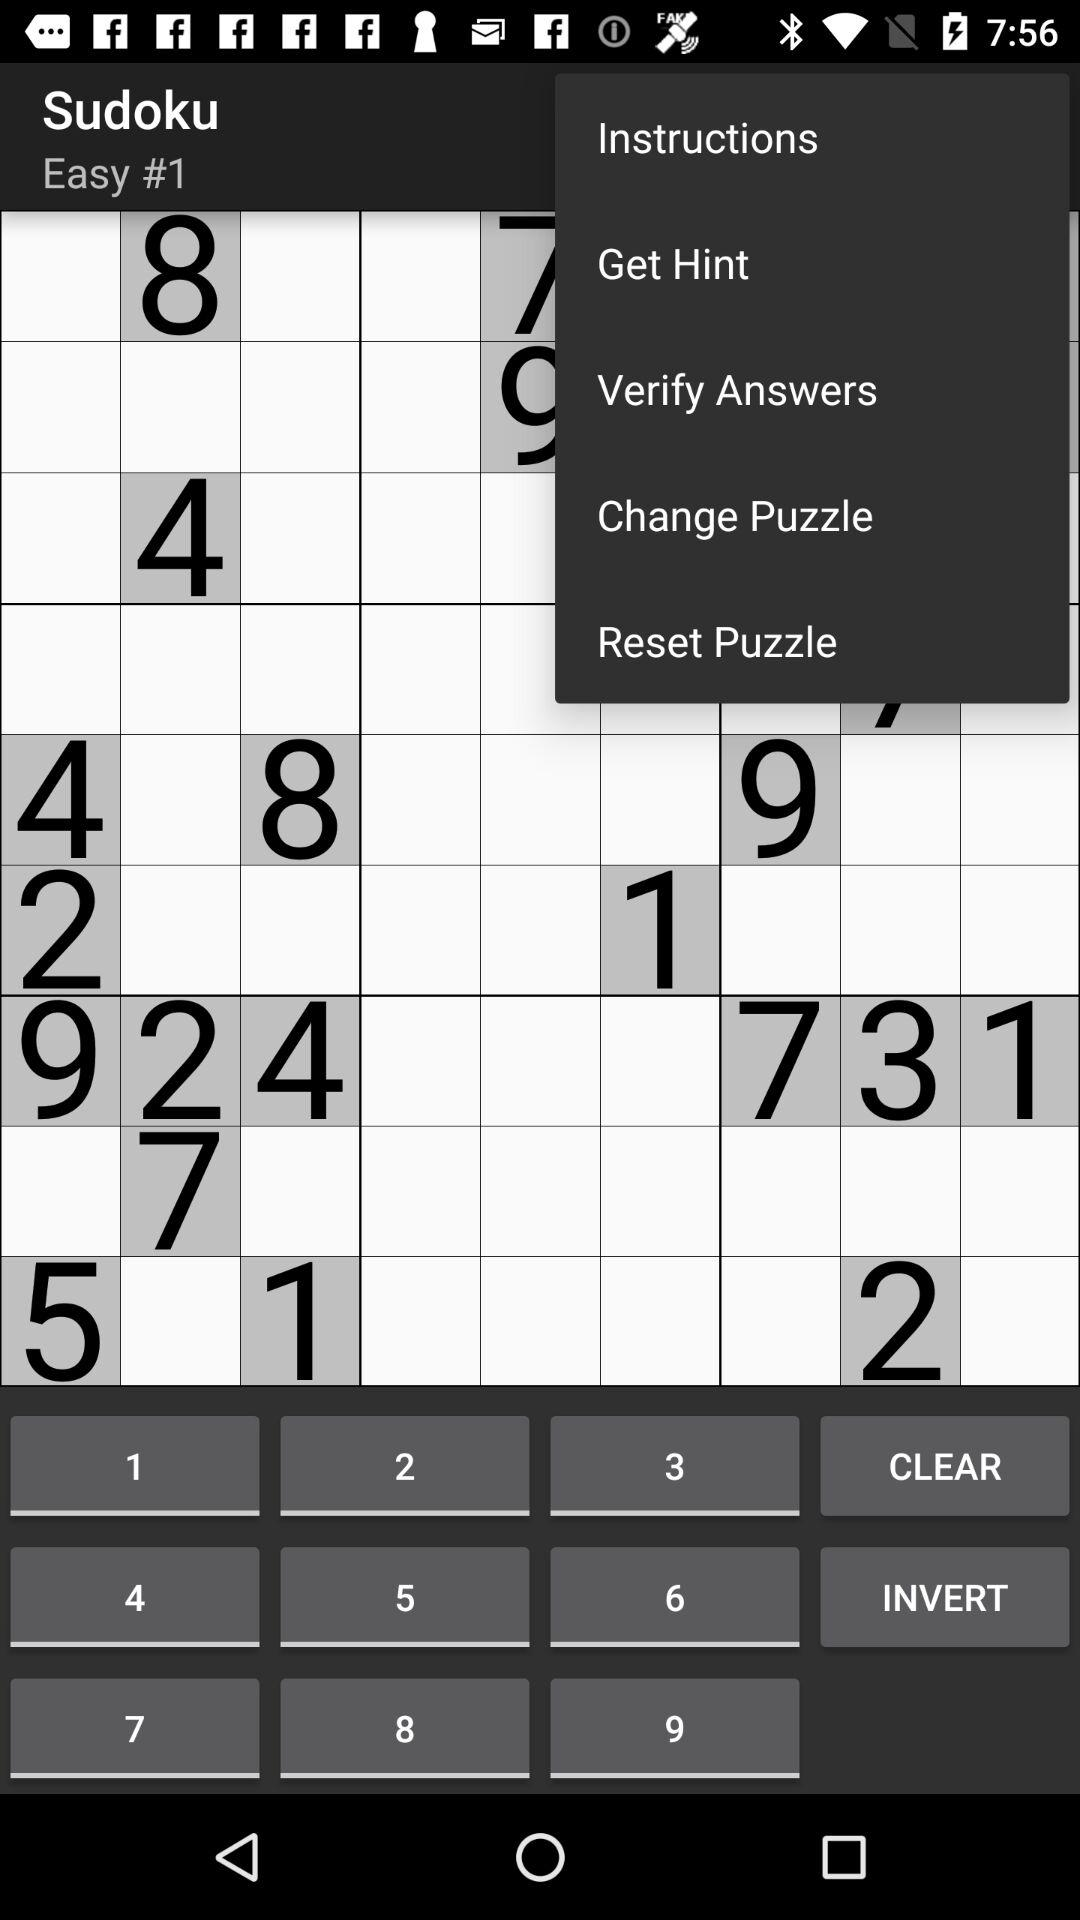What is the game level? The game level is easy. 